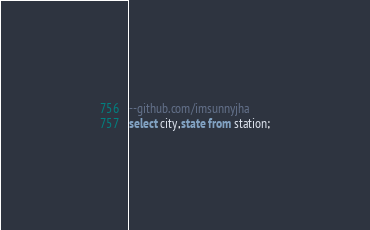<code> <loc_0><loc_0><loc_500><loc_500><_SQL_>--github.com/imsunnyjha
select city,state from station;</code> 